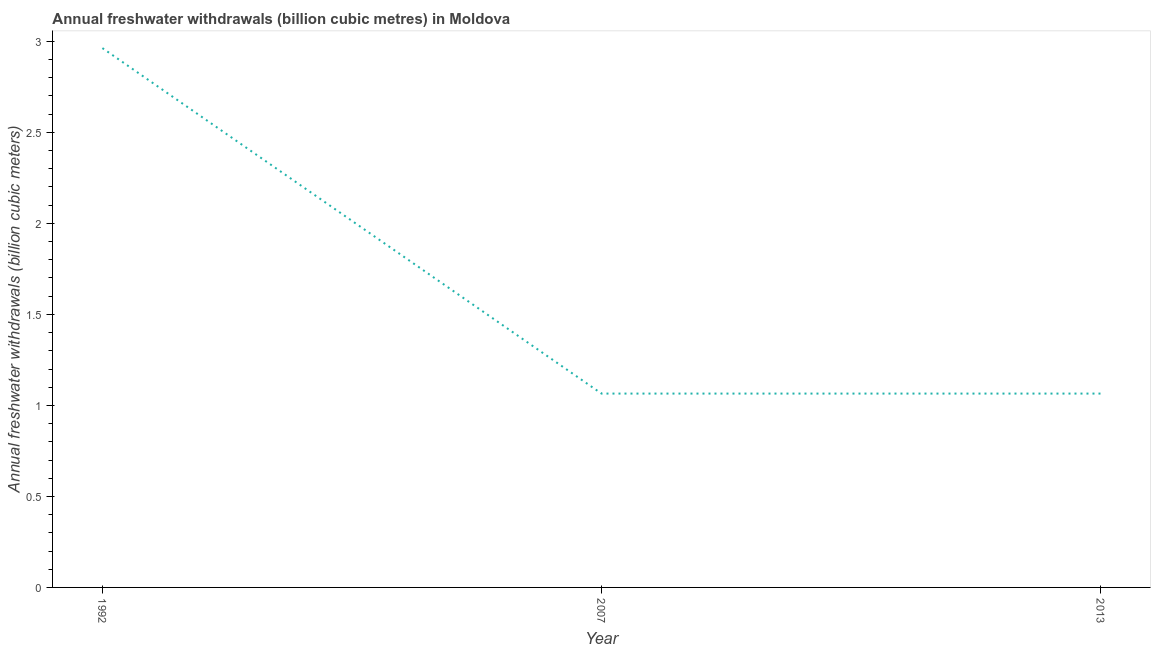What is the annual freshwater withdrawals in 2007?
Offer a very short reply. 1.06. Across all years, what is the maximum annual freshwater withdrawals?
Offer a very short reply. 2.96. Across all years, what is the minimum annual freshwater withdrawals?
Make the answer very short. 1.06. What is the sum of the annual freshwater withdrawals?
Keep it short and to the point. 5.09. What is the difference between the annual freshwater withdrawals in 1992 and 2013?
Provide a short and direct response. 1.9. What is the average annual freshwater withdrawals per year?
Your answer should be compact. 1.7. What is the median annual freshwater withdrawals?
Provide a short and direct response. 1.06. Do a majority of the years between 2013 and 1992 (inclusive) have annual freshwater withdrawals greater than 0.9 billion cubic meters?
Give a very brief answer. No. What is the ratio of the annual freshwater withdrawals in 1992 to that in 2007?
Make the answer very short. 2.78. Is the annual freshwater withdrawals in 1992 less than that in 2007?
Your answer should be compact. No. Is the difference between the annual freshwater withdrawals in 2007 and 2013 greater than the difference between any two years?
Ensure brevity in your answer.  No. What is the difference between the highest and the second highest annual freshwater withdrawals?
Make the answer very short. 1.9. What is the difference between the highest and the lowest annual freshwater withdrawals?
Provide a succinct answer. 1.9. Does the annual freshwater withdrawals monotonically increase over the years?
Give a very brief answer. No. How many years are there in the graph?
Keep it short and to the point. 3. Are the values on the major ticks of Y-axis written in scientific E-notation?
Provide a succinct answer. No. What is the title of the graph?
Your answer should be very brief. Annual freshwater withdrawals (billion cubic metres) in Moldova. What is the label or title of the X-axis?
Keep it short and to the point. Year. What is the label or title of the Y-axis?
Make the answer very short. Annual freshwater withdrawals (billion cubic meters). What is the Annual freshwater withdrawals (billion cubic meters) in 1992?
Give a very brief answer. 2.96. What is the Annual freshwater withdrawals (billion cubic meters) in 2007?
Your answer should be compact. 1.06. What is the Annual freshwater withdrawals (billion cubic meters) of 2013?
Keep it short and to the point. 1.06. What is the difference between the Annual freshwater withdrawals (billion cubic meters) in 1992 and 2007?
Keep it short and to the point. 1.9. What is the difference between the Annual freshwater withdrawals (billion cubic meters) in 1992 and 2013?
Provide a short and direct response. 1.9. What is the ratio of the Annual freshwater withdrawals (billion cubic meters) in 1992 to that in 2007?
Your answer should be compact. 2.78. What is the ratio of the Annual freshwater withdrawals (billion cubic meters) in 1992 to that in 2013?
Keep it short and to the point. 2.78. What is the ratio of the Annual freshwater withdrawals (billion cubic meters) in 2007 to that in 2013?
Your answer should be compact. 1. 